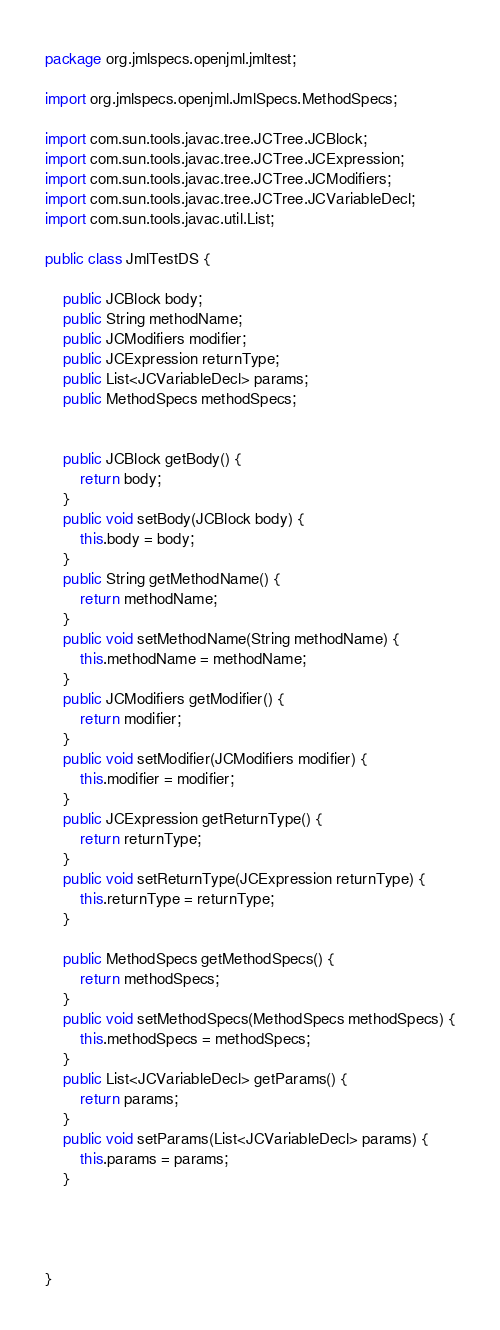Convert code to text. <code><loc_0><loc_0><loc_500><loc_500><_Java_>package org.jmlspecs.openjml.jmltest;

import org.jmlspecs.openjml.JmlSpecs.MethodSpecs;

import com.sun.tools.javac.tree.JCTree.JCBlock;
import com.sun.tools.javac.tree.JCTree.JCExpression;
import com.sun.tools.javac.tree.JCTree.JCModifiers;
import com.sun.tools.javac.tree.JCTree.JCVariableDecl;
import com.sun.tools.javac.util.List;

public class JmlTestDS {
    
    public JCBlock body;
    public String methodName;
    public JCModifiers modifier;
    public JCExpression returnType;
    public List<JCVariableDecl> params;
    public MethodSpecs methodSpecs;
    
    
    public JCBlock getBody() {
        return body;
    }
    public void setBody(JCBlock body) {
        this.body = body;
    }
    public String getMethodName() {
        return methodName;
    }
    public void setMethodName(String methodName) {
        this.methodName = methodName;
    }
    public JCModifiers getModifier() {
        return modifier;
    }
    public void setModifier(JCModifiers modifier) {
        this.modifier = modifier;
    }
    public JCExpression getReturnType() {
        return returnType;
    }
    public void setReturnType(JCExpression returnType) {
        this.returnType = returnType;
    }
    
    public MethodSpecs getMethodSpecs() {
        return methodSpecs;
    }
    public void setMethodSpecs(MethodSpecs methodSpecs) {
        this.methodSpecs = methodSpecs;
    }
    public List<JCVariableDecl> getParams() {
        return params;
    }
    public void setParams(List<JCVariableDecl> params) {
        this.params = params;
    }
    
    
    

}
</code> 